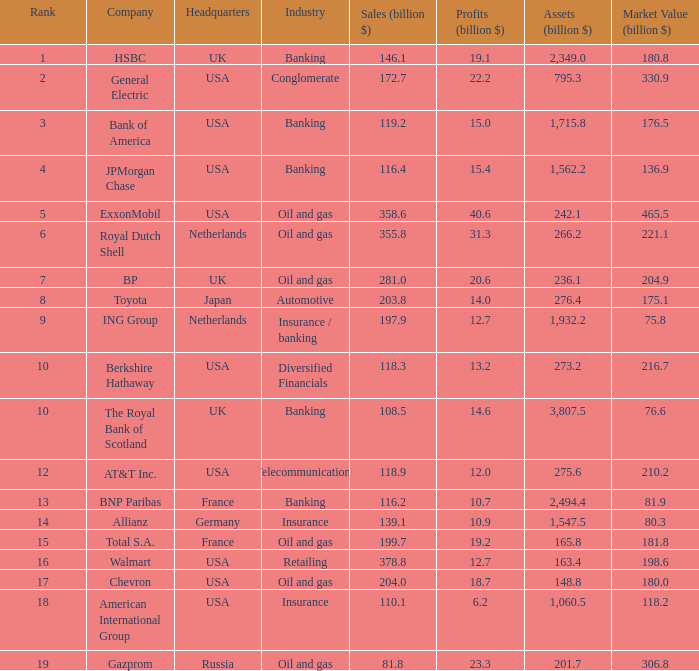What is the magnitude of profits in billions for enterprises with a market worth of 20 20.6. Would you mind parsing the complete table? {'header': ['Rank', 'Company', 'Headquarters', 'Industry', 'Sales (billion $)', 'Profits (billion $)', 'Assets (billion $)', 'Market Value (billion $)'], 'rows': [['1', 'HSBC', 'UK', 'Banking', '146.1', '19.1', '2,349.0', '180.8'], ['2', 'General Electric', 'USA', 'Conglomerate', '172.7', '22.2', '795.3', '330.9'], ['3', 'Bank of America', 'USA', 'Banking', '119.2', '15.0', '1,715.8', '176.5'], ['4', 'JPMorgan Chase', 'USA', 'Banking', '116.4', '15.4', '1,562.2', '136.9'], ['5', 'ExxonMobil', 'USA', 'Oil and gas', '358.6', '40.6', '242.1', '465.5'], ['6', 'Royal Dutch Shell', 'Netherlands', 'Oil and gas', '355.8', '31.3', '266.2', '221.1'], ['7', 'BP', 'UK', 'Oil and gas', '281.0', '20.6', '236.1', '204.9'], ['8', 'Toyota', 'Japan', 'Automotive', '203.8', '14.0', '276.4', '175.1'], ['9', 'ING Group', 'Netherlands', 'Insurance / banking', '197.9', '12.7', '1,932.2', '75.8'], ['10', 'Berkshire Hathaway', 'USA', 'Diversified Financials', '118.3', '13.2', '273.2', '216.7'], ['10', 'The Royal Bank of Scotland', 'UK', 'Banking', '108.5', '14.6', '3,807.5', '76.6'], ['12', 'AT&T Inc.', 'USA', 'Telecommunications', '118.9', '12.0', '275.6', '210.2'], ['13', 'BNP Paribas', 'France', 'Banking', '116.2', '10.7', '2,494.4', '81.9'], ['14', 'Allianz', 'Germany', 'Insurance', '139.1', '10.9', '1,547.5', '80.3'], ['15', 'Total S.A.', 'France', 'Oil and gas', '199.7', '19.2', '165.8', '181.8'], ['16', 'Walmart', 'USA', 'Retailing', '378.8', '12.7', '163.4', '198.6'], ['17', 'Chevron', 'USA', 'Oil and gas', '204.0', '18.7', '148.8', '180.0'], ['18', 'American International Group', 'USA', 'Insurance', '110.1', '6.2', '1,060.5', '118.2'], ['19', 'Gazprom', 'Russia', 'Oil and gas', '81.8', '23.3', '201.7', '306.8']]} 